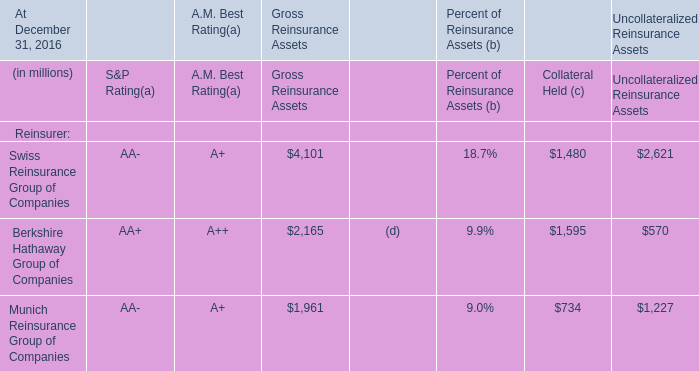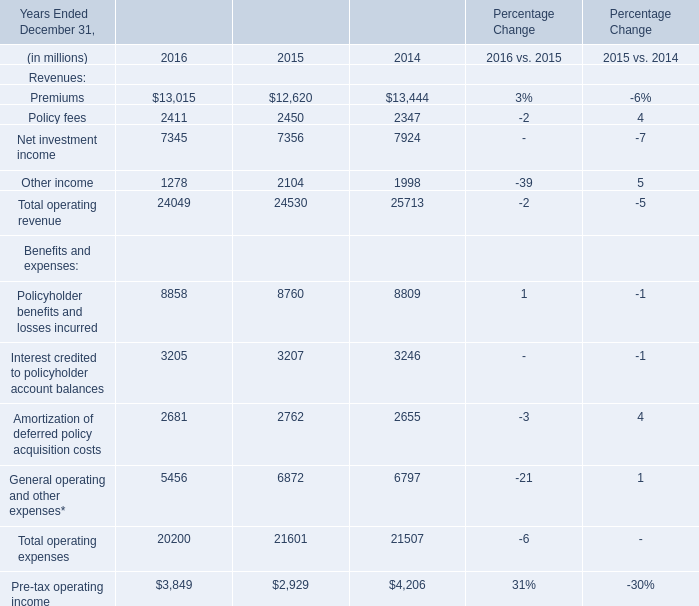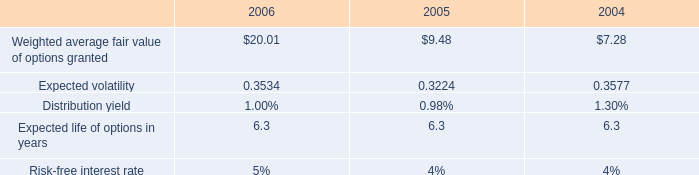What is the total amount of Policy fees of Percentage Change 2016, and Swiss Reinsurance Group of Companies of Uncollateralized Reinsurance Assets ? 
Computations: (2411.0 + 2621.0)
Answer: 5032.0. 